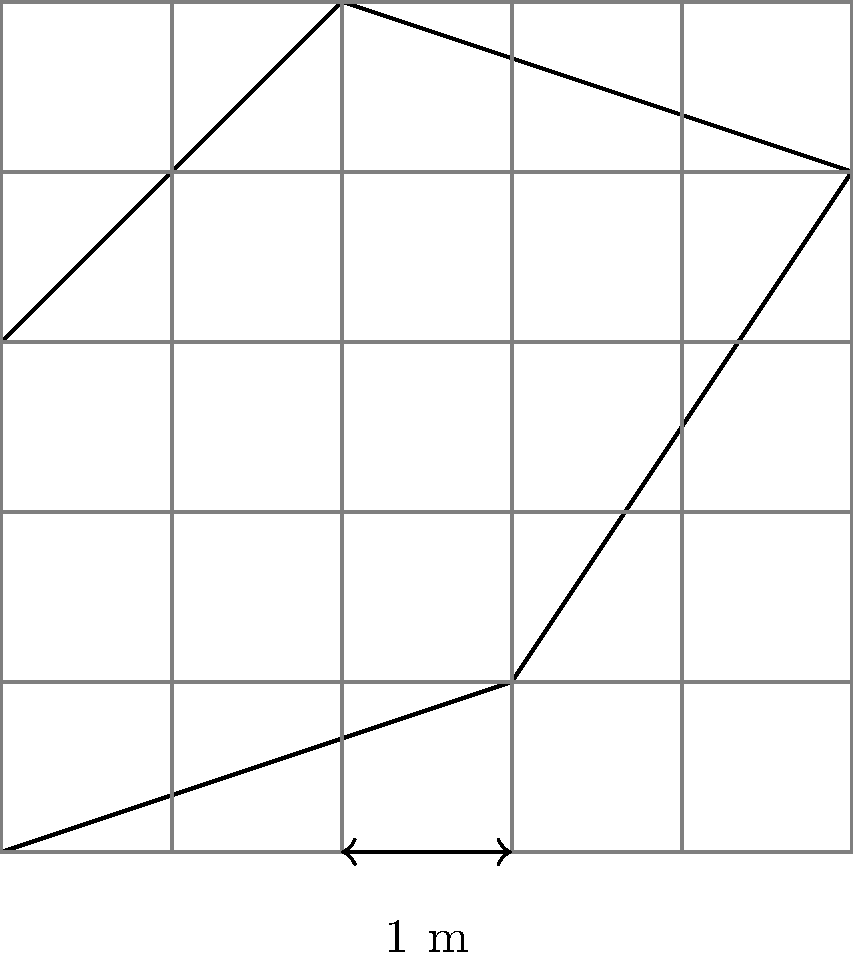You're excavating an irregularly shaped archaeological site. Using the grid overlay method, where each square represents 1 square meter, estimate the area of the dig site. Round your answer to the nearest whole number. To estimate the area using the grid method:

1. Count full squares within the site:
   There are 9 full squares.

2. Count partial squares:
   There are 12 partial squares.

3. Estimate partial squares:
   Assume each partial square is about half full on average.
   12 partial squares ≈ 6 full squares

4. Sum the total:
   Full squares + Estimated partial squares
   $9 + 6 = 15$ square meters

5. Round to the nearest whole number:
   15 square meters (already a whole number)

Therefore, the estimated area of the archaeological dig site is 15 square meters.
Answer: 15 square meters 